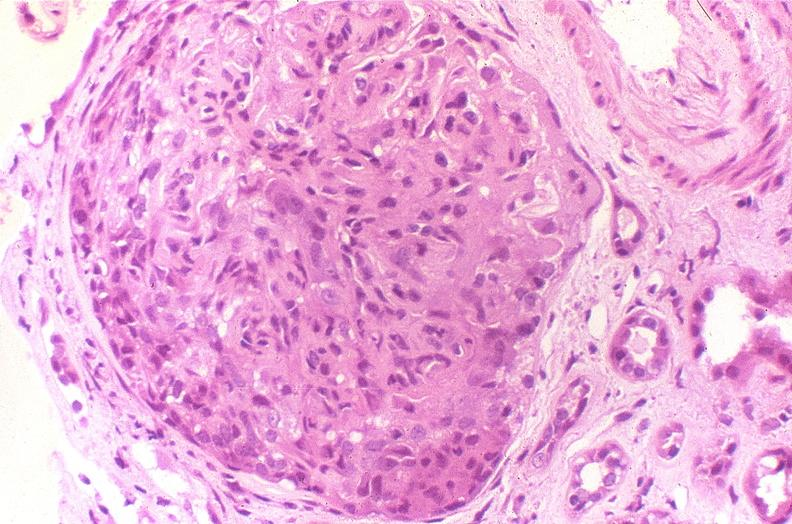does stomach show glomerulonephritis, sle iv?
Answer the question using a single word or phrase. No 